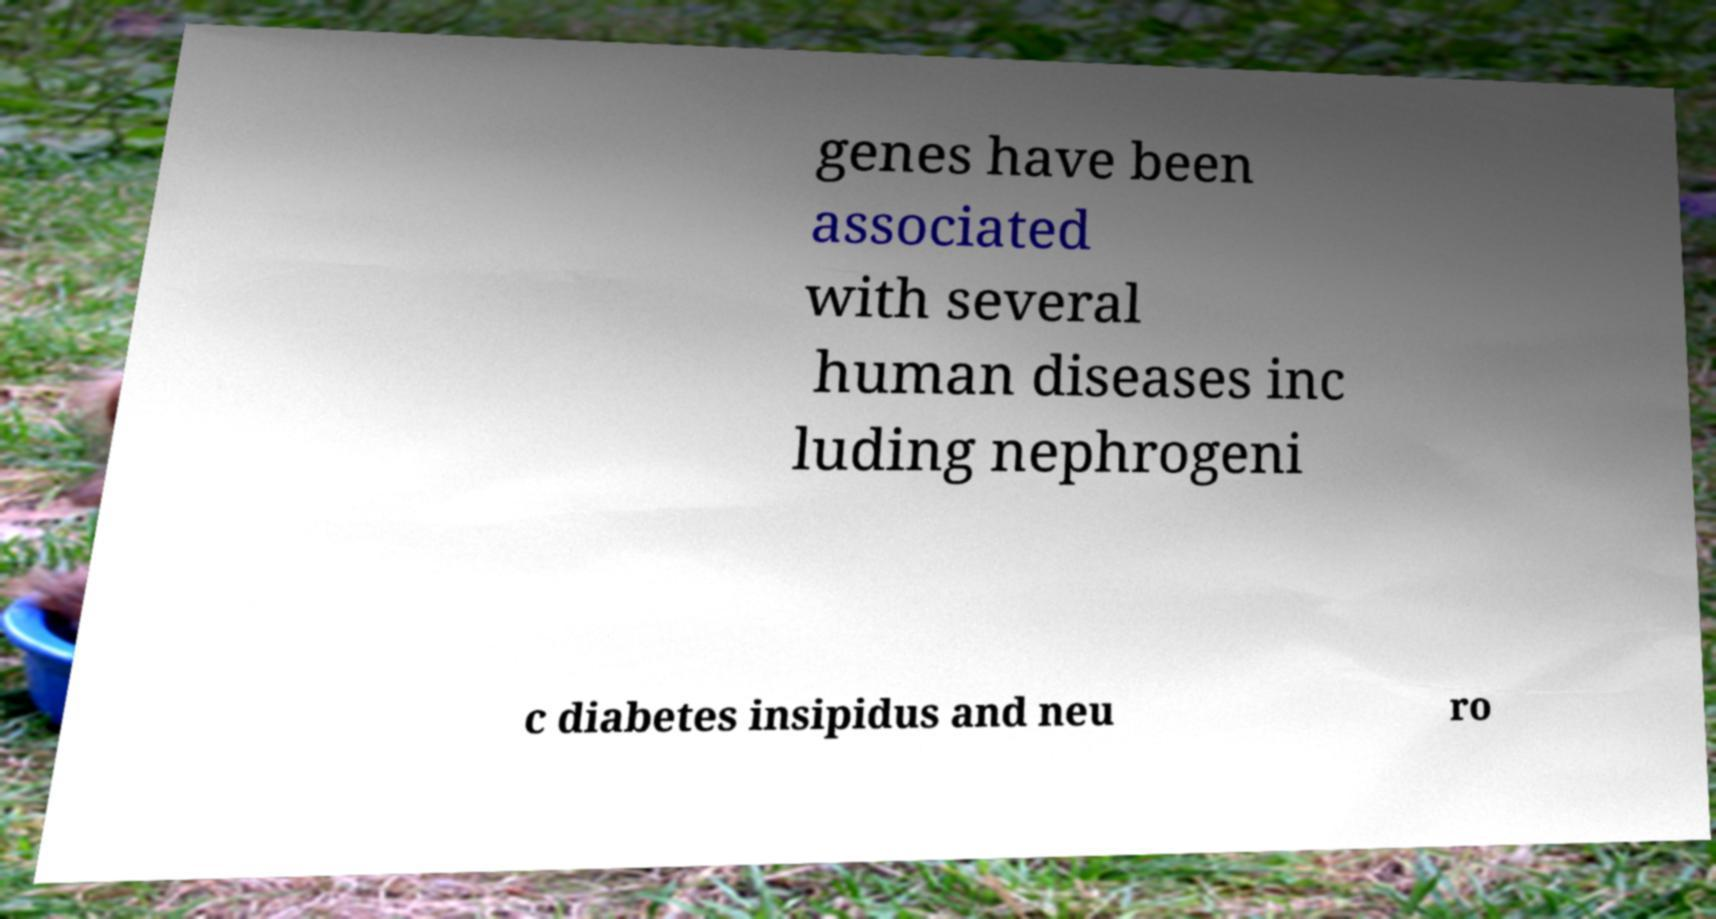Please identify and transcribe the text found in this image. genes have been associated with several human diseases inc luding nephrogeni c diabetes insipidus and neu ro 